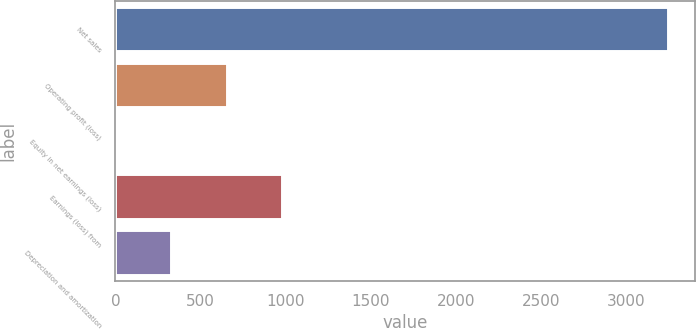Convert chart to OTSL. <chart><loc_0><loc_0><loc_500><loc_500><bar_chart><fcel>Net sales<fcel>Operating profit (loss)<fcel>Equity in net earnings (loss)<fcel>Earnings (loss) from<fcel>Depreciation and amortization<nl><fcel>3241<fcel>652.2<fcel>5<fcel>975.8<fcel>328.6<nl></chart> 